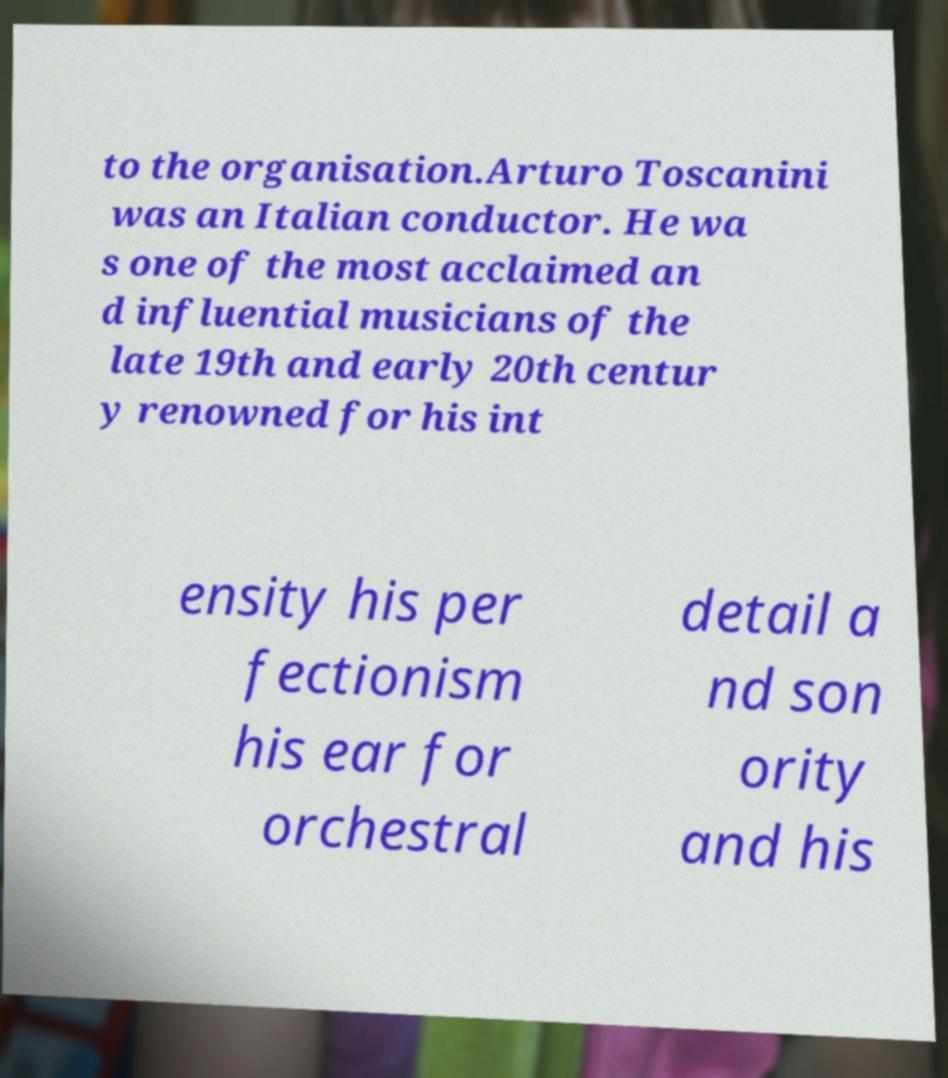Could you assist in decoding the text presented in this image and type it out clearly? to the organisation.Arturo Toscanini was an Italian conductor. He wa s one of the most acclaimed an d influential musicians of the late 19th and early 20th centur y renowned for his int ensity his per fectionism his ear for orchestral detail a nd son ority and his 